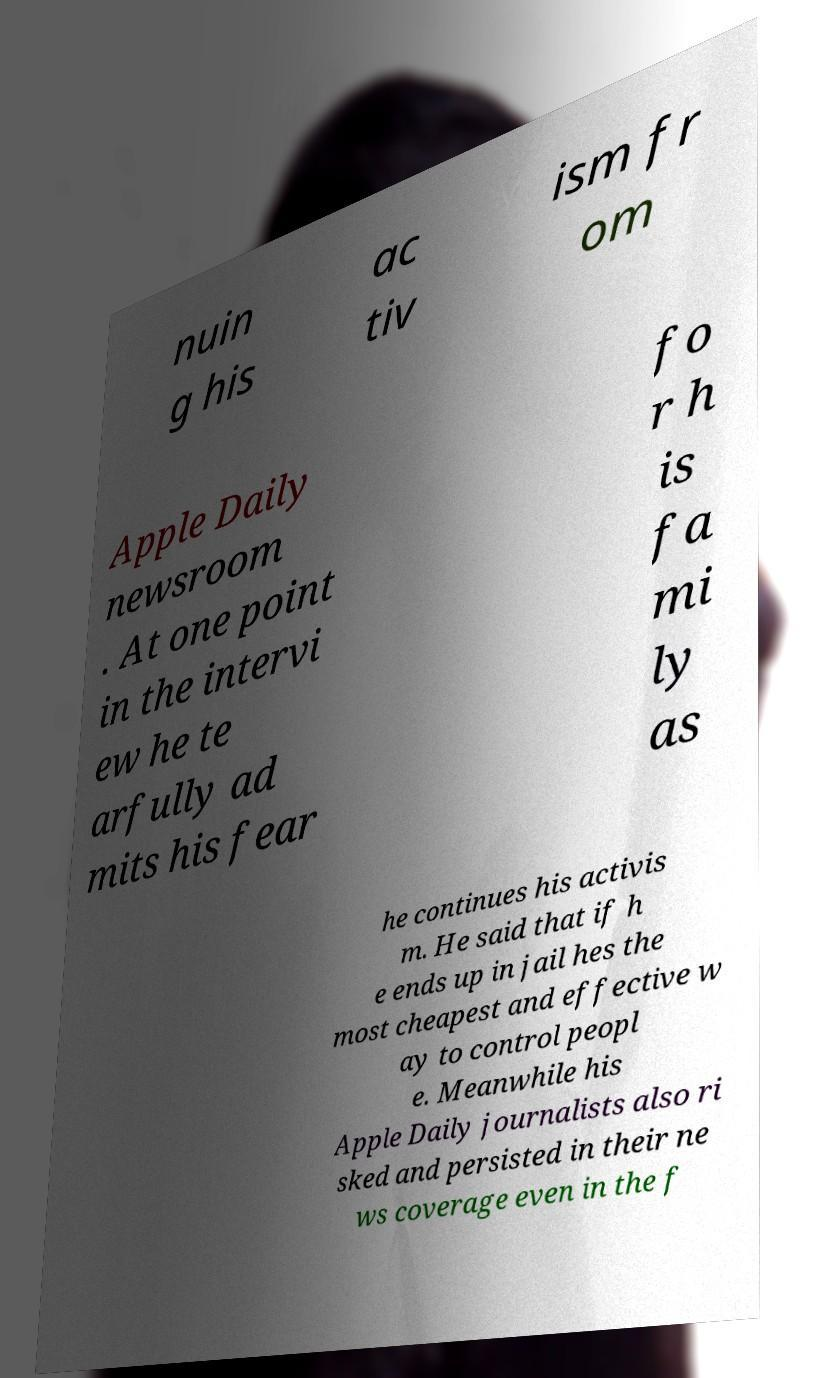Please identify and transcribe the text found in this image. nuin g his ac tiv ism fr om Apple Daily newsroom . At one point in the intervi ew he te arfully ad mits his fear fo r h is fa mi ly as he continues his activis m. He said that if h e ends up in jail hes the most cheapest and effective w ay to control peopl e. Meanwhile his Apple Daily journalists also ri sked and persisted in their ne ws coverage even in the f 